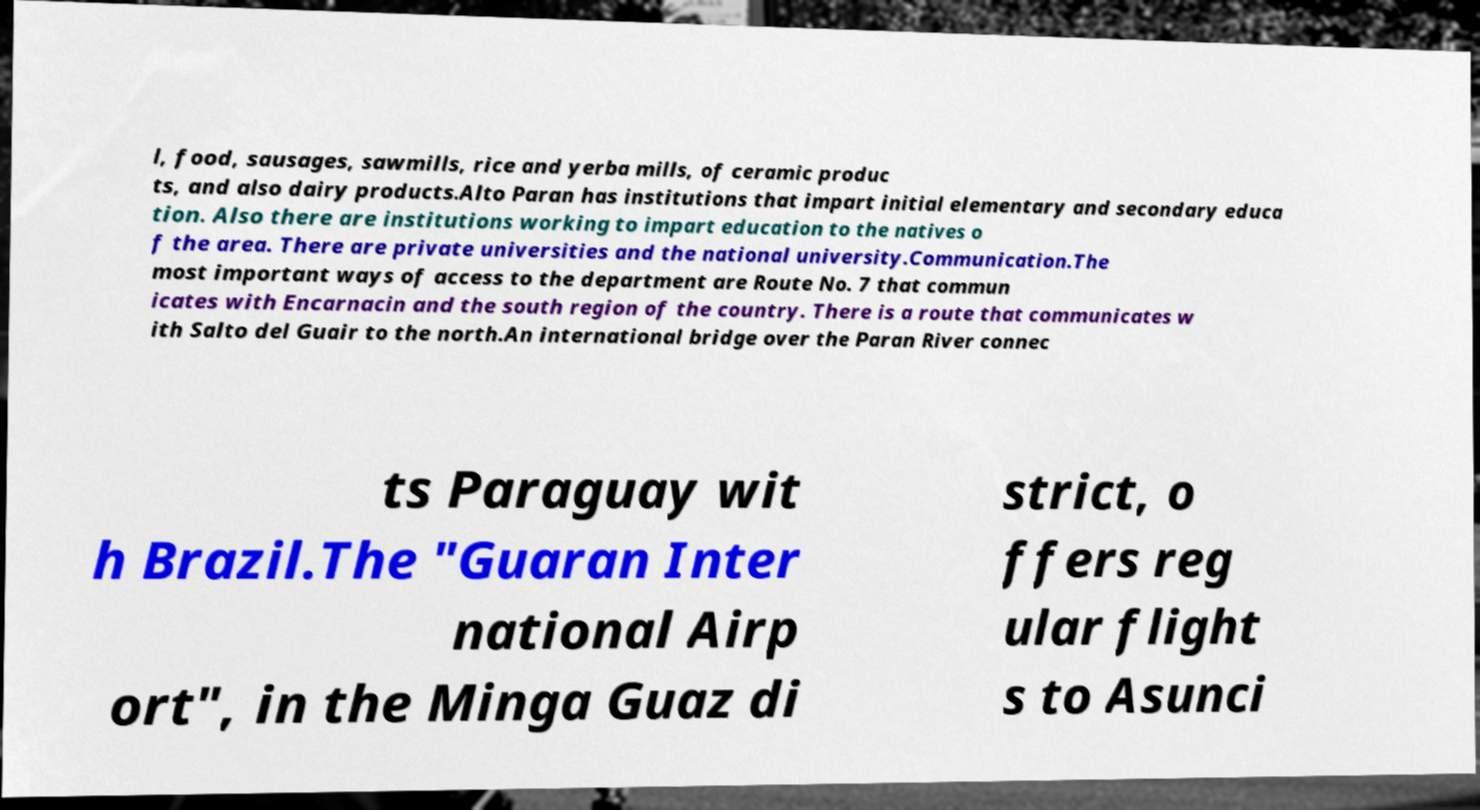There's text embedded in this image that I need extracted. Can you transcribe it verbatim? l, food, sausages, sawmills, rice and yerba mills, of ceramic produc ts, and also dairy products.Alto Paran has institutions that impart initial elementary and secondary educa tion. Also there are institutions working to impart education to the natives o f the area. There are private universities and the national university.Communication.The most important ways of access to the department are Route No. 7 that commun icates with Encarnacin and the south region of the country. There is a route that communicates w ith Salto del Guair to the north.An international bridge over the Paran River connec ts Paraguay wit h Brazil.The "Guaran Inter national Airp ort", in the Minga Guaz di strict, o ffers reg ular flight s to Asunci 